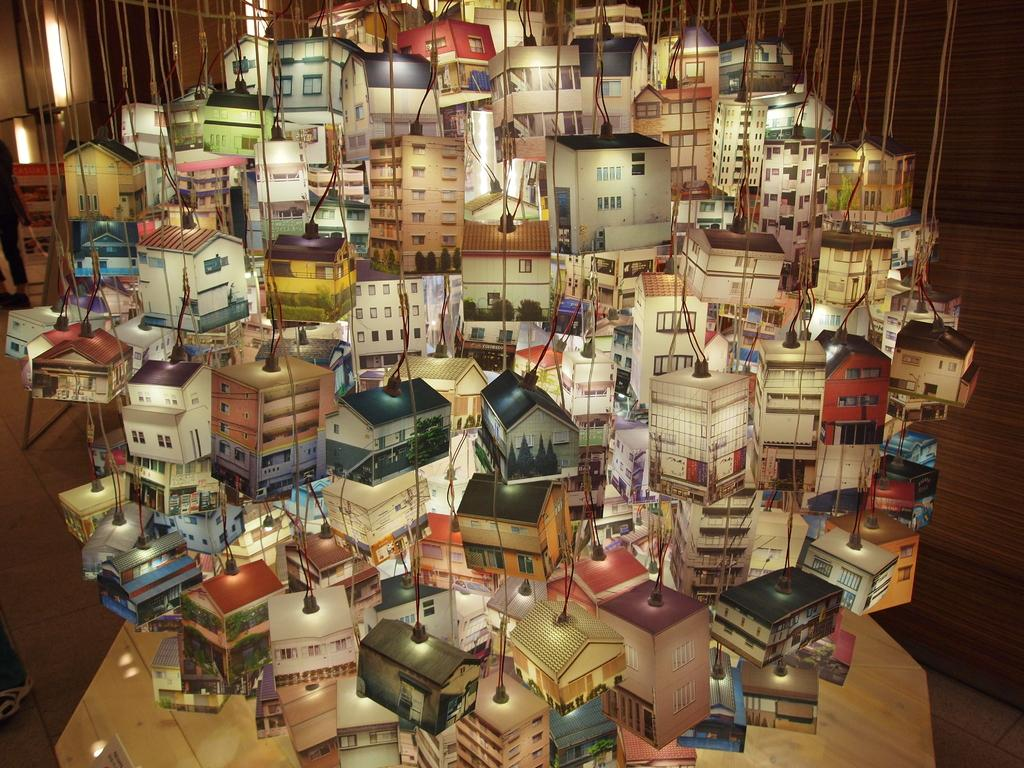What can be seen in the image that is related to illumination? There are lights in the image. How have the lights been modified or arranged? The lights have been changed to resemble houses and buildings. How many toes can be seen on the flowers in the image? There are no flowers or toes present in the image; it features lights changed to resemble houses and buildings. 